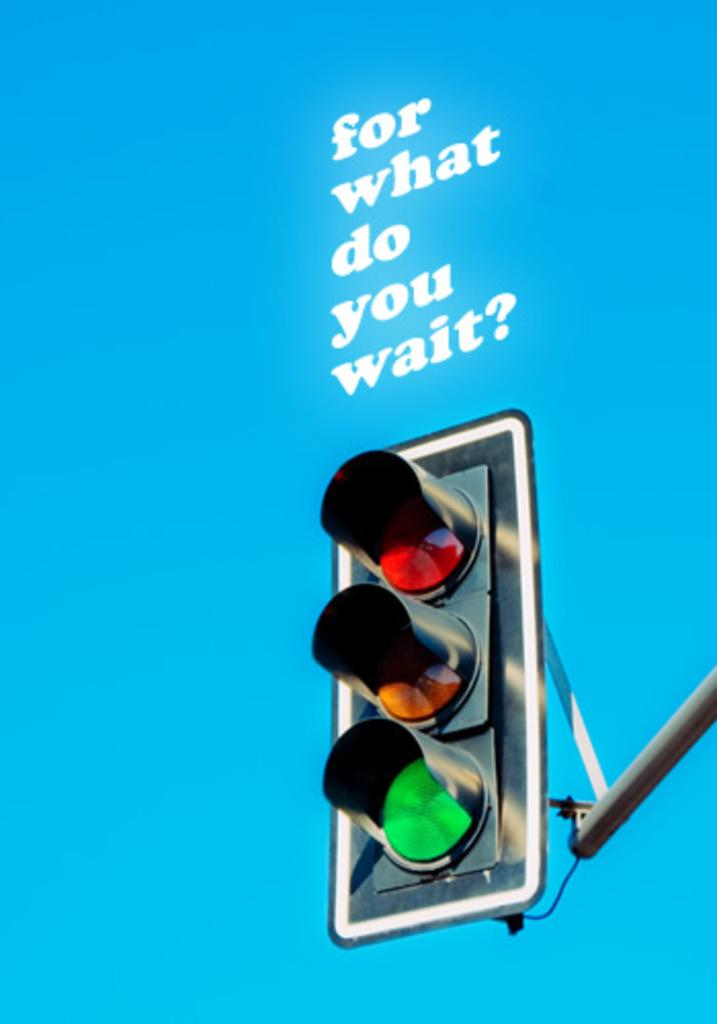<image>
Render a clear and concise summary of the photo. Above a traffic light asks For What do you wait. 